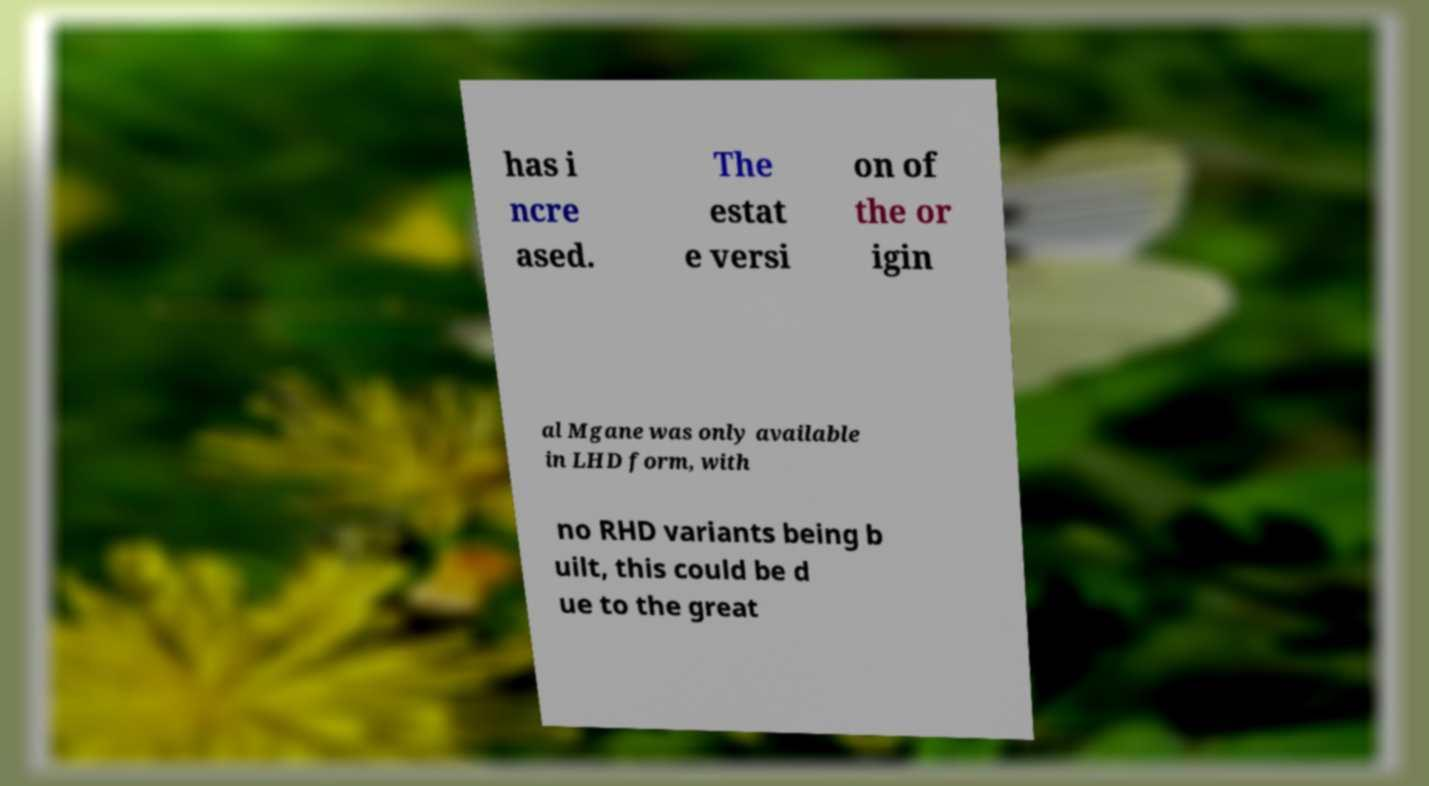What messages or text are displayed in this image? I need them in a readable, typed format. has i ncre ased. The estat e versi on of the or igin al Mgane was only available in LHD form, with no RHD variants being b uilt, this could be d ue to the great 